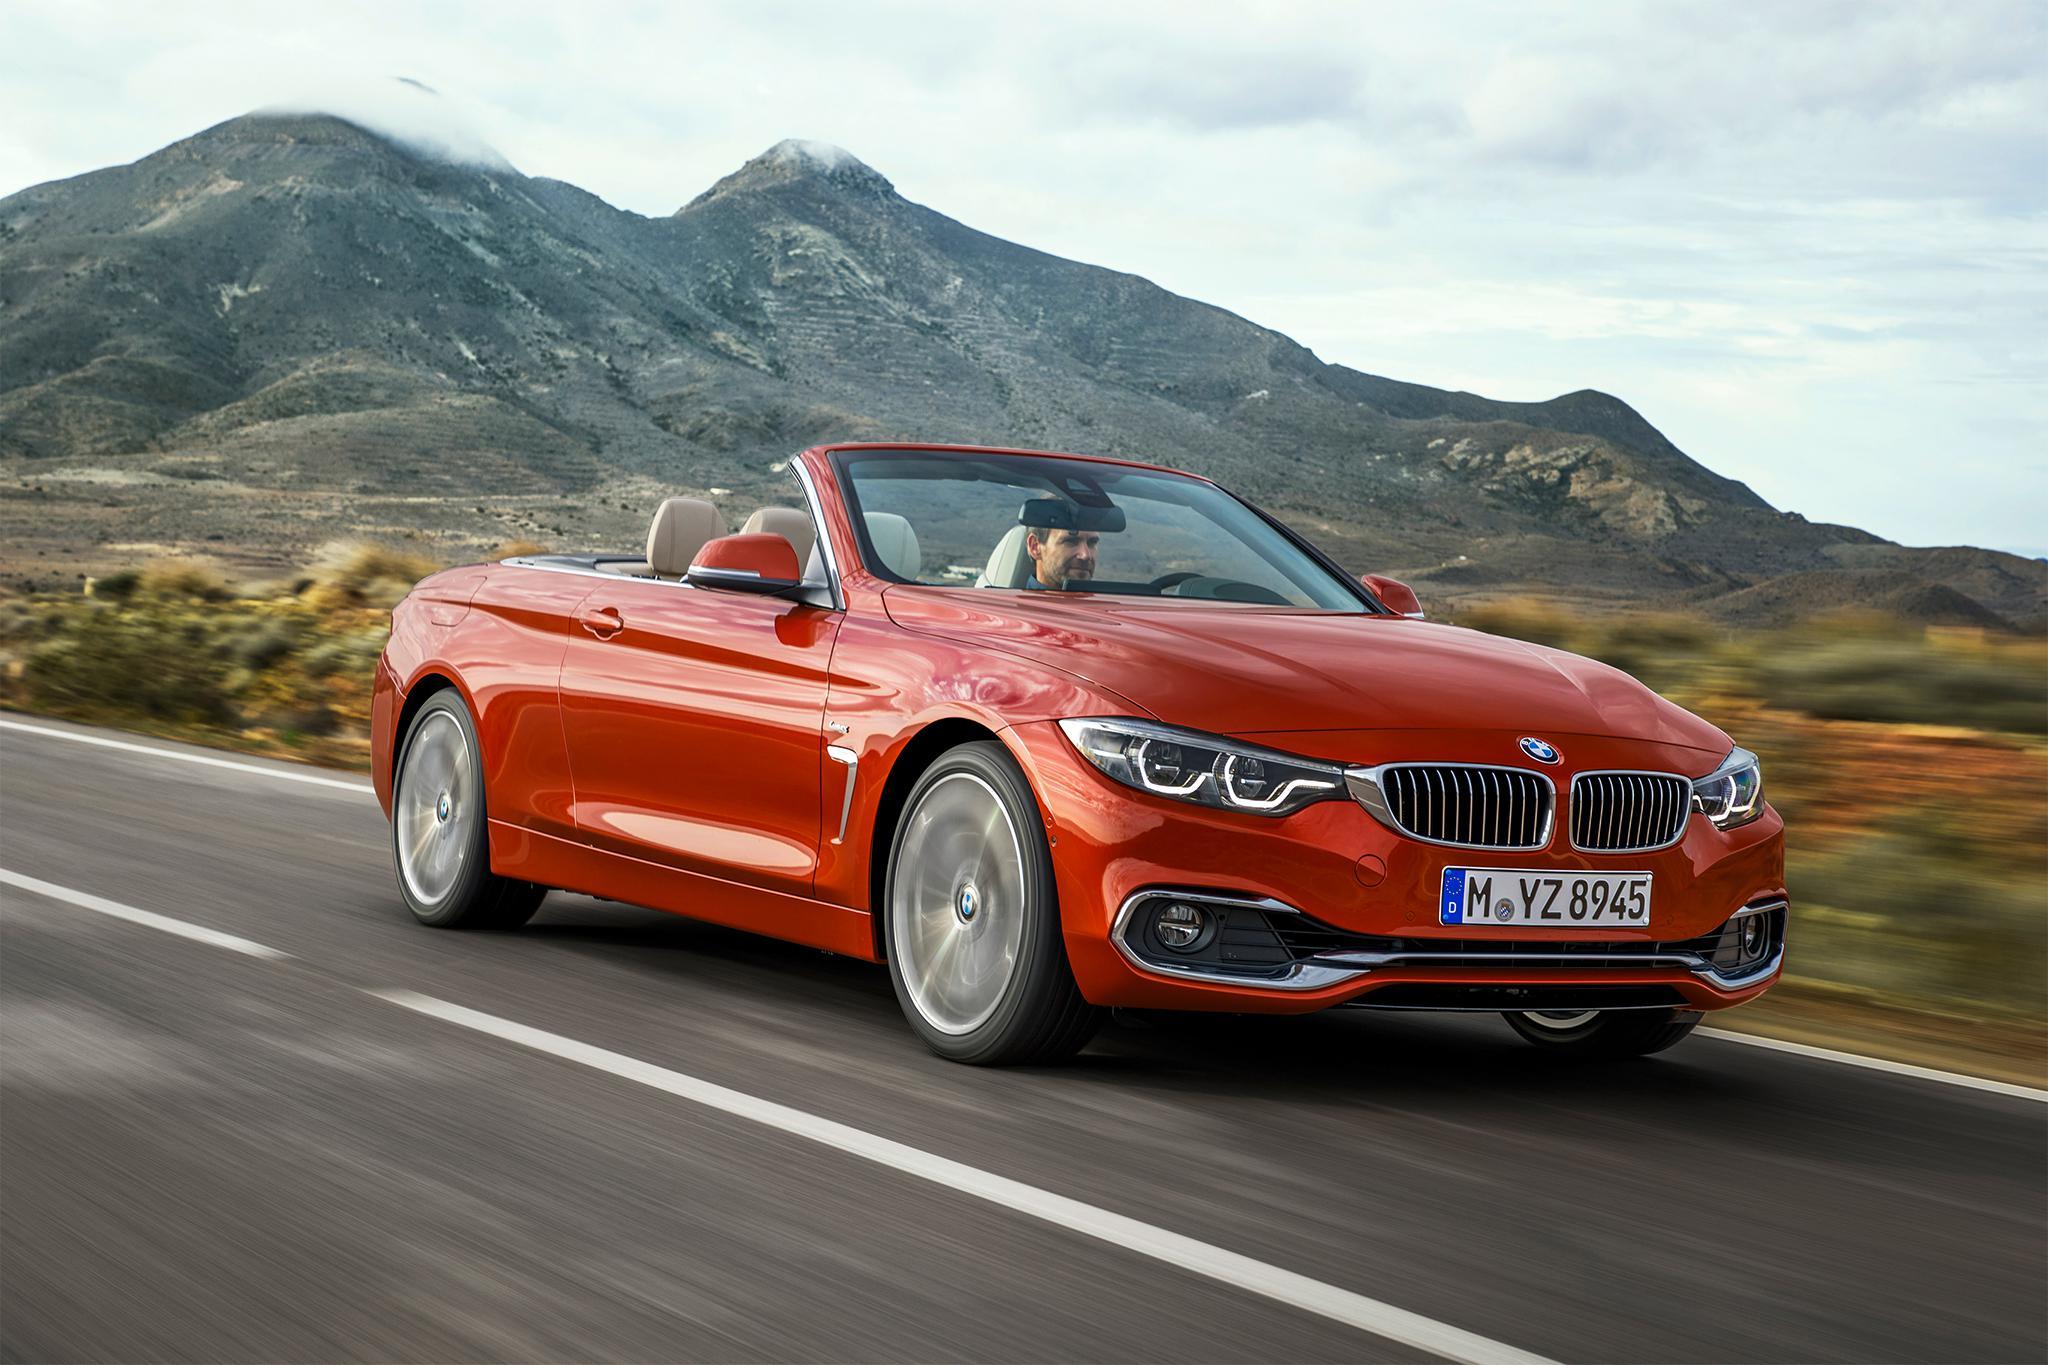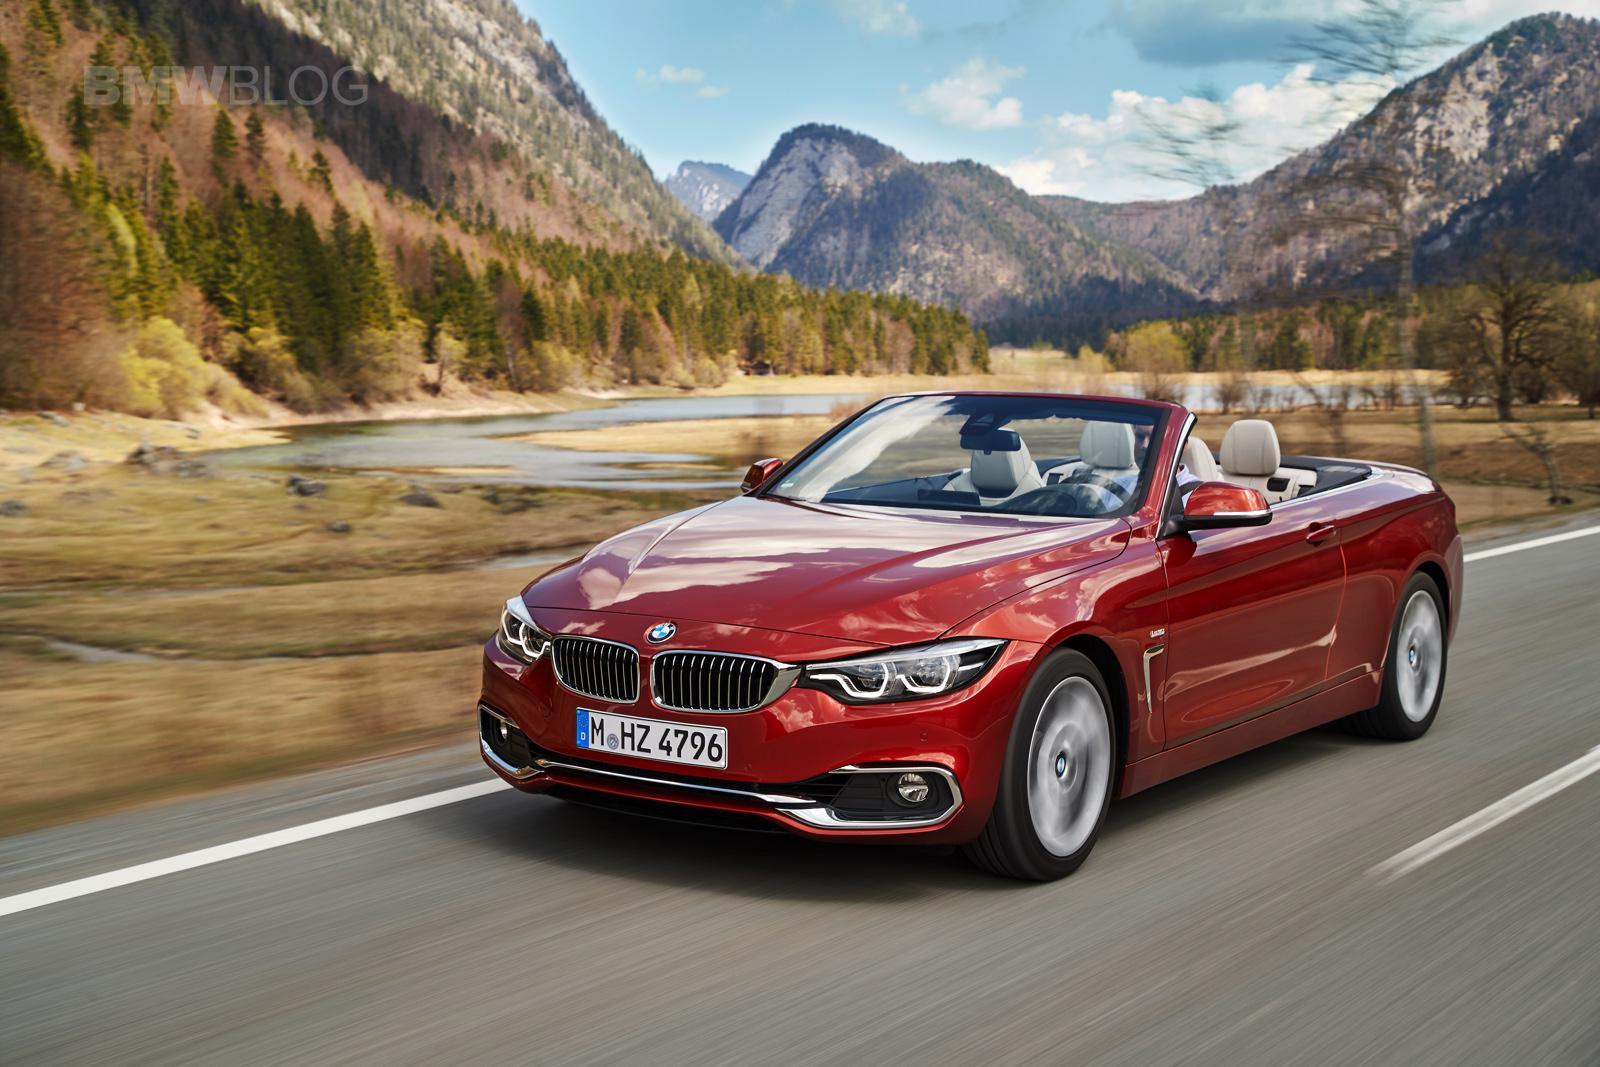The first image is the image on the left, the second image is the image on the right. Analyze the images presented: Is the assertion "One image features a red convertible and a blue car with a top, and the vehicles face opposite directions." valid? Answer yes or no. No. The first image is the image on the left, the second image is the image on the right. For the images displayed, is the sentence "The left hand image shows one red and one blue car, while the right hand image shows exactly one red convertible vehicle." factually correct? Answer yes or no. No. 